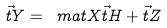Convert formula to latex. <formula><loc_0><loc_0><loc_500><loc_500>\vec { t } { Y } = \ m a t { X } \vec { t } { H } + \vec { t } { Z }</formula> 